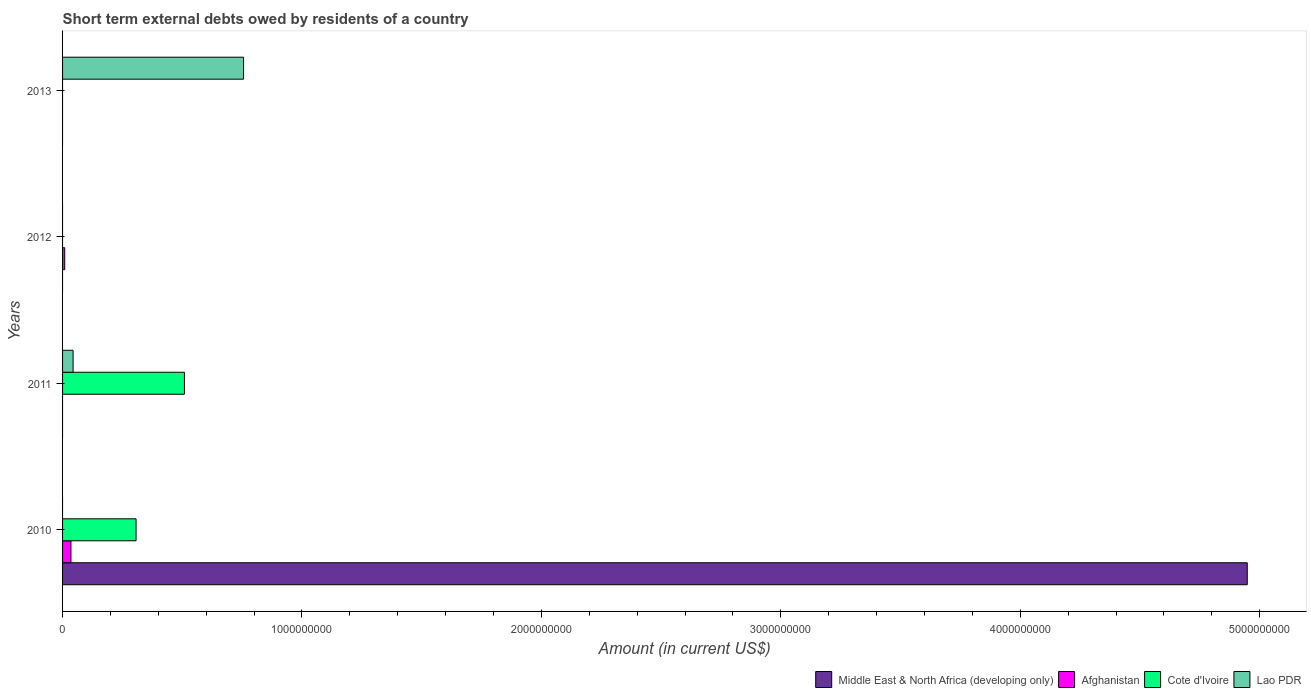Are the number of bars per tick equal to the number of legend labels?
Ensure brevity in your answer.  No. Are the number of bars on each tick of the Y-axis equal?
Keep it short and to the point. No. How many bars are there on the 4th tick from the top?
Provide a short and direct response. 3. How many bars are there on the 4th tick from the bottom?
Offer a very short reply. 1. What is the label of the 3rd group of bars from the top?
Keep it short and to the point. 2011. In how many cases, is the number of bars for a given year not equal to the number of legend labels?
Provide a succinct answer. 4. What is the amount of short-term external debts owed by residents in Cote d'Ivoire in 2010?
Give a very brief answer. 3.07e+08. Across all years, what is the maximum amount of short-term external debts owed by residents in Afghanistan?
Your answer should be very brief. 3.50e+07. Across all years, what is the minimum amount of short-term external debts owed by residents in Cote d'Ivoire?
Ensure brevity in your answer.  0. What is the total amount of short-term external debts owed by residents in Lao PDR in the graph?
Your answer should be very brief. 8.00e+08. What is the difference between the amount of short-term external debts owed by residents in Lao PDR in 2011 and that in 2013?
Give a very brief answer. -7.12e+08. What is the difference between the amount of short-term external debts owed by residents in Middle East & North Africa (developing only) in 2010 and the amount of short-term external debts owed by residents in Afghanistan in 2012?
Offer a very short reply. 4.94e+09. What is the average amount of short-term external debts owed by residents in Cote d'Ivoire per year?
Provide a succinct answer. 2.04e+08. In the year 2011, what is the difference between the amount of short-term external debts owed by residents in Lao PDR and amount of short-term external debts owed by residents in Cote d'Ivoire?
Make the answer very short. -4.65e+08. Is the amount of short-term external debts owed by residents in Lao PDR in 2011 less than that in 2013?
Keep it short and to the point. Yes. What is the difference between the highest and the lowest amount of short-term external debts owed by residents in Lao PDR?
Give a very brief answer. 7.56e+08. In how many years, is the amount of short-term external debts owed by residents in Middle East & North Africa (developing only) greater than the average amount of short-term external debts owed by residents in Middle East & North Africa (developing only) taken over all years?
Offer a very short reply. 1. How many bars are there?
Give a very brief answer. 7. Are all the bars in the graph horizontal?
Provide a short and direct response. Yes. How many years are there in the graph?
Your answer should be very brief. 4. What is the difference between two consecutive major ticks on the X-axis?
Your answer should be compact. 1.00e+09. Does the graph contain any zero values?
Make the answer very short. Yes. Does the graph contain grids?
Give a very brief answer. No. What is the title of the graph?
Your response must be concise. Short term external debts owed by residents of a country. Does "Egypt, Arab Rep." appear as one of the legend labels in the graph?
Offer a terse response. No. What is the label or title of the Y-axis?
Your answer should be very brief. Years. What is the Amount (in current US$) in Middle East & North Africa (developing only) in 2010?
Offer a terse response. 4.95e+09. What is the Amount (in current US$) in Afghanistan in 2010?
Provide a succinct answer. 3.50e+07. What is the Amount (in current US$) of Cote d'Ivoire in 2010?
Your answer should be compact. 3.07e+08. What is the Amount (in current US$) in Lao PDR in 2010?
Provide a short and direct response. 0. What is the Amount (in current US$) of Afghanistan in 2011?
Give a very brief answer. 0. What is the Amount (in current US$) of Cote d'Ivoire in 2011?
Offer a terse response. 5.09e+08. What is the Amount (in current US$) of Lao PDR in 2011?
Your answer should be very brief. 4.40e+07. What is the Amount (in current US$) of Middle East & North Africa (developing only) in 2012?
Your answer should be compact. 0. What is the Amount (in current US$) in Afghanistan in 2012?
Offer a terse response. 9.00e+06. What is the Amount (in current US$) in Cote d'Ivoire in 2012?
Offer a terse response. 0. What is the Amount (in current US$) of Afghanistan in 2013?
Provide a short and direct response. 0. What is the Amount (in current US$) in Lao PDR in 2013?
Your answer should be very brief. 7.56e+08. Across all years, what is the maximum Amount (in current US$) of Middle East & North Africa (developing only)?
Your answer should be very brief. 4.95e+09. Across all years, what is the maximum Amount (in current US$) of Afghanistan?
Offer a terse response. 3.50e+07. Across all years, what is the maximum Amount (in current US$) of Cote d'Ivoire?
Provide a short and direct response. 5.09e+08. Across all years, what is the maximum Amount (in current US$) of Lao PDR?
Make the answer very short. 7.56e+08. Across all years, what is the minimum Amount (in current US$) of Afghanistan?
Offer a terse response. 0. Across all years, what is the minimum Amount (in current US$) in Cote d'Ivoire?
Your answer should be compact. 0. Across all years, what is the minimum Amount (in current US$) in Lao PDR?
Provide a succinct answer. 0. What is the total Amount (in current US$) in Middle East & North Africa (developing only) in the graph?
Your answer should be compact. 4.95e+09. What is the total Amount (in current US$) of Afghanistan in the graph?
Make the answer very short. 4.40e+07. What is the total Amount (in current US$) in Cote d'Ivoire in the graph?
Ensure brevity in your answer.  8.16e+08. What is the total Amount (in current US$) of Lao PDR in the graph?
Your answer should be compact. 8.00e+08. What is the difference between the Amount (in current US$) in Cote d'Ivoire in 2010 and that in 2011?
Your answer should be compact. -2.02e+08. What is the difference between the Amount (in current US$) in Afghanistan in 2010 and that in 2012?
Make the answer very short. 2.60e+07. What is the difference between the Amount (in current US$) in Lao PDR in 2011 and that in 2013?
Provide a short and direct response. -7.12e+08. What is the difference between the Amount (in current US$) of Middle East & North Africa (developing only) in 2010 and the Amount (in current US$) of Cote d'Ivoire in 2011?
Give a very brief answer. 4.44e+09. What is the difference between the Amount (in current US$) in Middle East & North Africa (developing only) in 2010 and the Amount (in current US$) in Lao PDR in 2011?
Make the answer very short. 4.90e+09. What is the difference between the Amount (in current US$) in Afghanistan in 2010 and the Amount (in current US$) in Cote d'Ivoire in 2011?
Make the answer very short. -4.74e+08. What is the difference between the Amount (in current US$) of Afghanistan in 2010 and the Amount (in current US$) of Lao PDR in 2011?
Your answer should be compact. -9.00e+06. What is the difference between the Amount (in current US$) in Cote d'Ivoire in 2010 and the Amount (in current US$) in Lao PDR in 2011?
Keep it short and to the point. 2.63e+08. What is the difference between the Amount (in current US$) in Middle East & North Africa (developing only) in 2010 and the Amount (in current US$) in Afghanistan in 2012?
Your response must be concise. 4.94e+09. What is the difference between the Amount (in current US$) of Middle East & North Africa (developing only) in 2010 and the Amount (in current US$) of Lao PDR in 2013?
Your answer should be compact. 4.19e+09. What is the difference between the Amount (in current US$) in Afghanistan in 2010 and the Amount (in current US$) in Lao PDR in 2013?
Keep it short and to the point. -7.21e+08. What is the difference between the Amount (in current US$) in Cote d'Ivoire in 2010 and the Amount (in current US$) in Lao PDR in 2013?
Make the answer very short. -4.49e+08. What is the difference between the Amount (in current US$) in Cote d'Ivoire in 2011 and the Amount (in current US$) in Lao PDR in 2013?
Make the answer very short. -2.47e+08. What is the difference between the Amount (in current US$) of Afghanistan in 2012 and the Amount (in current US$) of Lao PDR in 2013?
Your answer should be compact. -7.47e+08. What is the average Amount (in current US$) in Middle East & North Africa (developing only) per year?
Offer a very short reply. 1.24e+09. What is the average Amount (in current US$) of Afghanistan per year?
Offer a terse response. 1.10e+07. What is the average Amount (in current US$) in Cote d'Ivoire per year?
Your answer should be very brief. 2.04e+08. What is the average Amount (in current US$) in Lao PDR per year?
Give a very brief answer. 2.00e+08. In the year 2010, what is the difference between the Amount (in current US$) in Middle East & North Africa (developing only) and Amount (in current US$) in Afghanistan?
Provide a succinct answer. 4.91e+09. In the year 2010, what is the difference between the Amount (in current US$) in Middle East & North Africa (developing only) and Amount (in current US$) in Cote d'Ivoire?
Make the answer very short. 4.64e+09. In the year 2010, what is the difference between the Amount (in current US$) in Afghanistan and Amount (in current US$) in Cote d'Ivoire?
Keep it short and to the point. -2.72e+08. In the year 2011, what is the difference between the Amount (in current US$) in Cote d'Ivoire and Amount (in current US$) in Lao PDR?
Your answer should be compact. 4.65e+08. What is the ratio of the Amount (in current US$) in Cote d'Ivoire in 2010 to that in 2011?
Your response must be concise. 0.6. What is the ratio of the Amount (in current US$) of Afghanistan in 2010 to that in 2012?
Your answer should be compact. 3.89. What is the ratio of the Amount (in current US$) of Lao PDR in 2011 to that in 2013?
Offer a terse response. 0.06. What is the difference between the highest and the lowest Amount (in current US$) of Middle East & North Africa (developing only)?
Your response must be concise. 4.95e+09. What is the difference between the highest and the lowest Amount (in current US$) of Afghanistan?
Provide a short and direct response. 3.50e+07. What is the difference between the highest and the lowest Amount (in current US$) of Cote d'Ivoire?
Your response must be concise. 5.09e+08. What is the difference between the highest and the lowest Amount (in current US$) of Lao PDR?
Your answer should be very brief. 7.56e+08. 